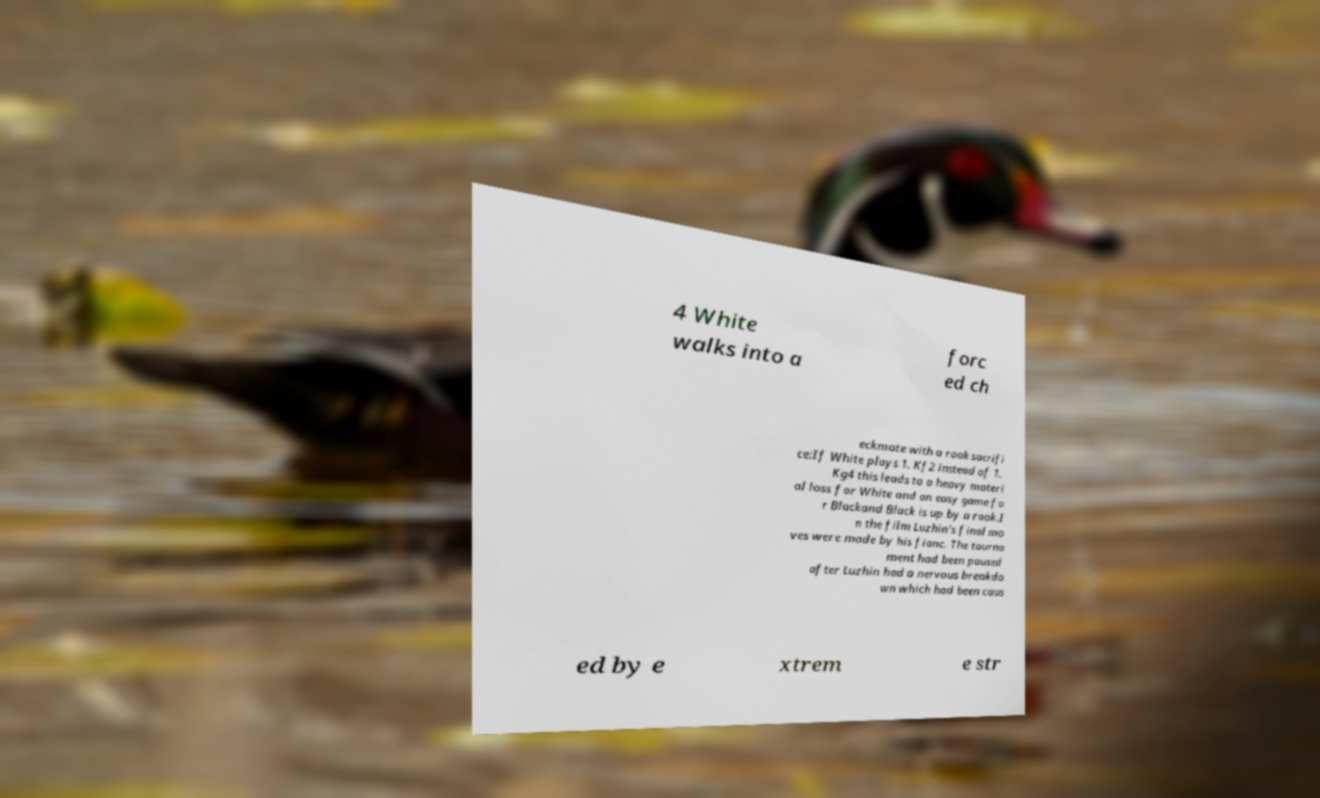Can you read and provide the text displayed in the image?This photo seems to have some interesting text. Can you extract and type it out for me? 4 White walks into a forc ed ch eckmate with a rook sacrifi ce:If White plays 1. Kf2 instead of 1. Kg4 this leads to a heavy materi al loss for White and an easy game fo r Blackand Black is up by a rook.I n the film Luzhin's final mo ves were made by his fianc. The tourna ment had been paused after Luzhin had a nervous breakdo wn which had been caus ed by e xtrem e str 